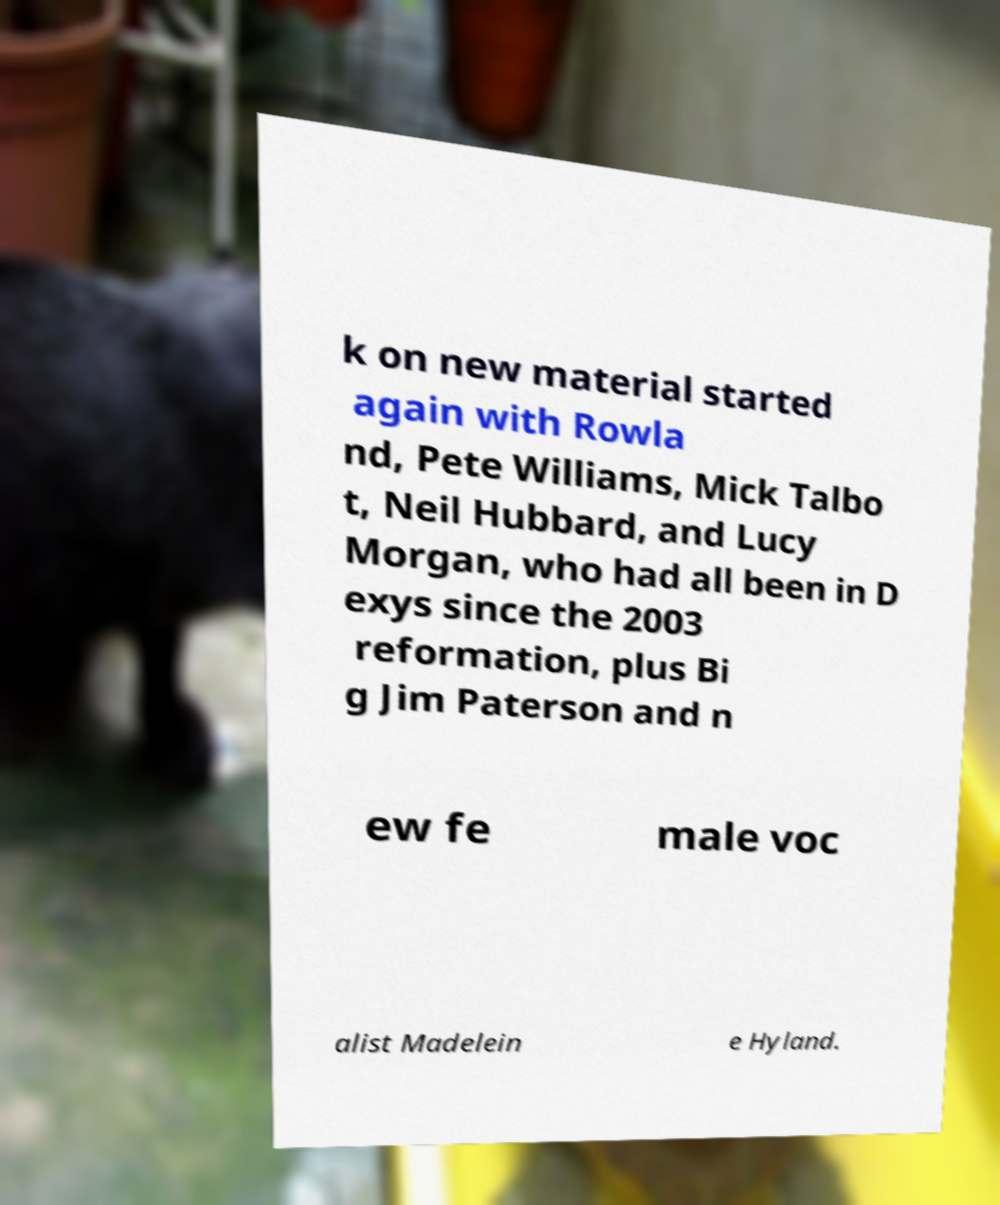For documentation purposes, I need the text within this image transcribed. Could you provide that? k on new material started again with Rowla nd, Pete Williams, Mick Talbo t, Neil Hubbard, and Lucy Morgan, who had all been in D exys since the 2003 reformation, plus Bi g Jim Paterson and n ew fe male voc alist Madelein e Hyland. 